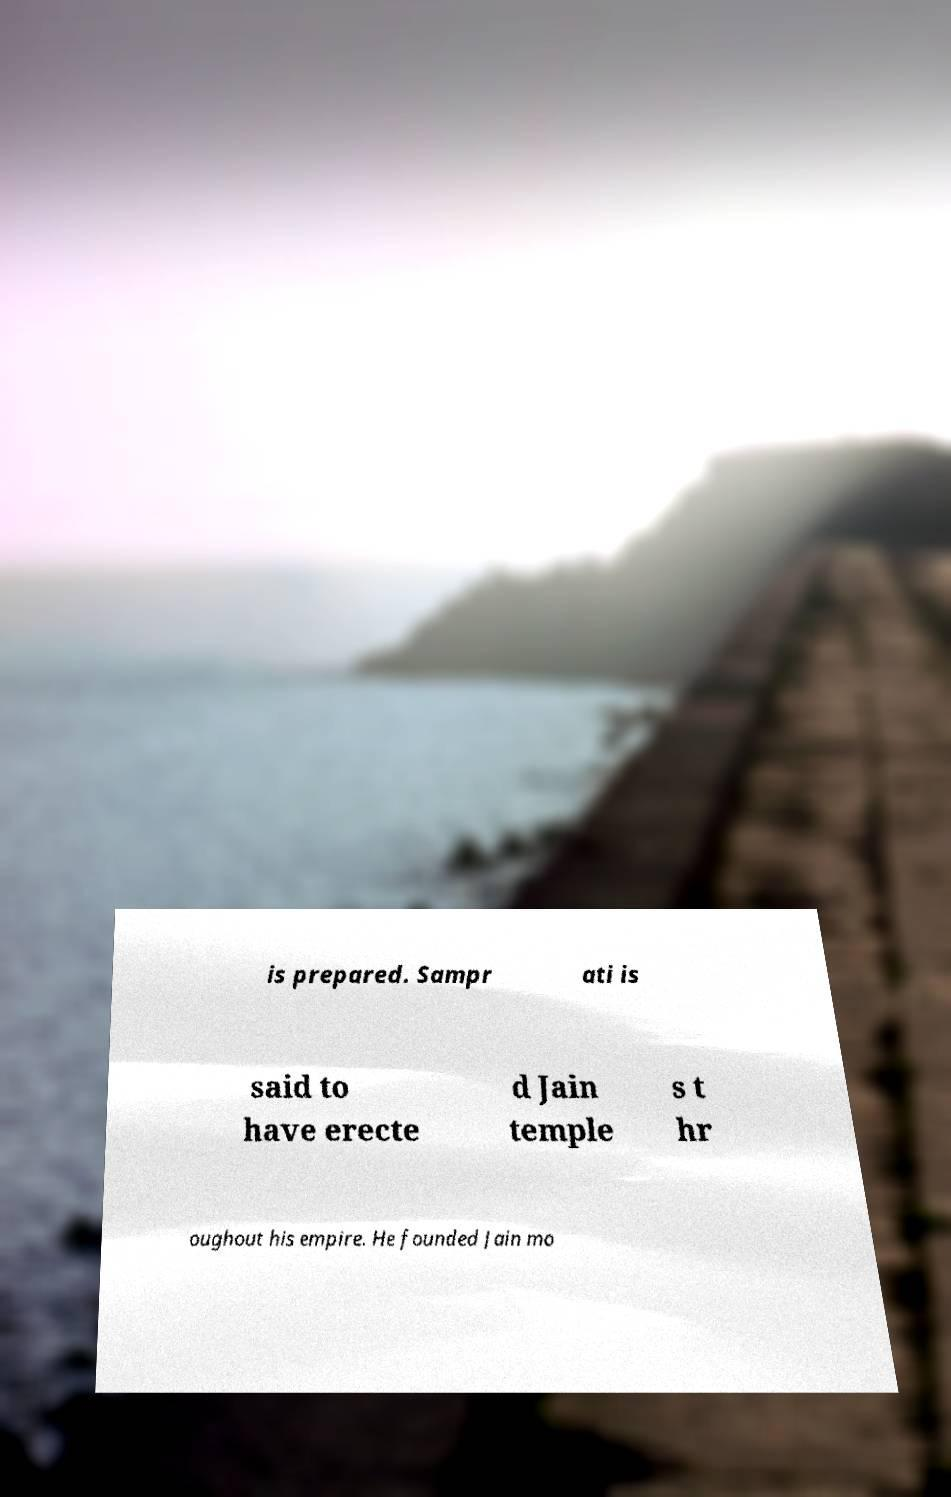Please identify and transcribe the text found in this image. is prepared. Sampr ati is said to have erecte d Jain temple s t hr oughout his empire. He founded Jain mo 